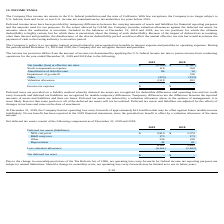According to Sunworks's financial document, What is the valuation allowance in 2019? According to the financial document, 2,518. The relevant text states: "Valuation allowance 2,518 833..." Also, Where does the company file income tax returns? in the U.S. federal jurisdiction and the state of California. The document states: "INCOME TAXES The Company files income tax returns in the U.S. federal jurisdiction and the state of California. With few exceptions, the Company is no..." Also, What is the net loss at effective tax rates in 2019? According to the financial document, 2,508. The relevant text states: "Net taxable (loss) at effective tax rates $ (2,508) $ (1,567)..." Also, can you calculate: What is the percentage change in the net loss at effective tax rates from 2018 to 2019? To answer this question, I need to perform calculations using the financial data. The calculation is: (2,508-1,567)/1,567, which equals 60.05 (percentage). This is based on the information: "Net taxable (loss) at effective tax rates $ (2,508) $ (1,567) axable (loss) at effective tax rates $ (2,508) $ (1,567)..." The key data points involved are: 1,567, 2,508. Also, can you calculate: What is the percentage change in the stock compensation expense from 2018 to 2019? To answer this question, I need to perform calculations using the financial data. The calculation is: (119-358)/358, which equals -66.76 (percentage). This is based on the information: "Stock compensation expense 119 358 Stock compensation expense 119 358..." The key data points involved are: 119, 358. Also, can you calculate: What is the percentage change in the valuation allowance from 2018 to 2019? To answer this question, I need to perform calculations using the financial data. The calculation is: (2,518-833)/833, which equals 202.28 (percentage). This is based on the information: "Valuation allowance 2,518 833 Valuation allowance 2,518 833..." The key data points involved are: 2,518, 833. 